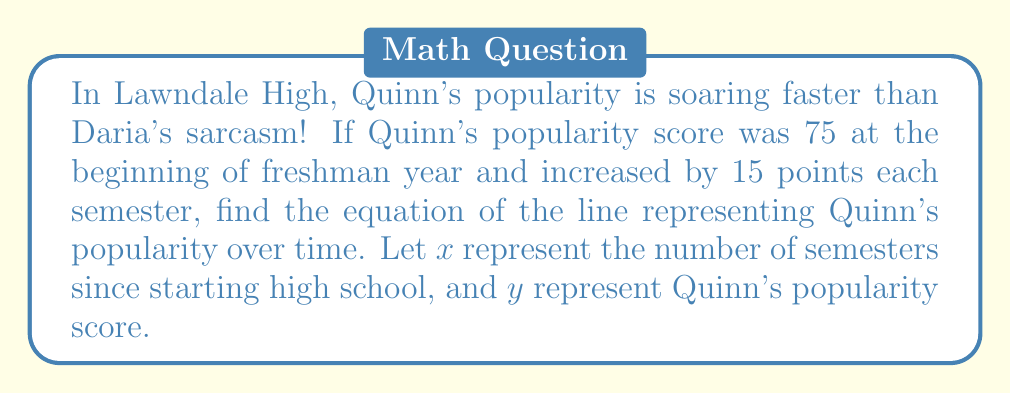What is the answer to this math problem? To find the equation of the line, we need to use the point-slope form: $y - y_1 = m(x - x_1)$

Step 1: Identify the given information:
- Initial popularity score (y-intercept): $y = 75$ when $x = 0$
- Rate of increase (slope): 15 points per semester

Step 2: Determine the slope (m):
$m = 15$

Step 3: Use the point-slope form with the initial point $(0, 75)$:
$y - 75 = 15(x - 0)$

Step 4: Simplify the equation:
$y - 75 = 15x$

Step 5: Solve for y to get the slope-intercept form:
$y = 15x + 75$

This equation represents Quinn's popularity score (y) as a function of the number of semesters (x) since starting high school.
Answer: $y = 15x + 75$ 